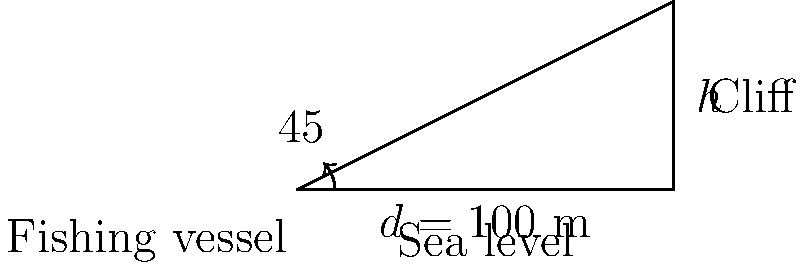A fishing vessel is positioned 100 meters from the base of a coastal cliff. Using a theodolite, the fisherman measures the angle of elevation to the top of the cliff to be 45°. What is the height of the cliff? To solve this problem, we can use trigonometry. Let's break it down step-by-step:

1) We have a right-angled triangle where:
   - The base (adjacent side) is the distance from the fishing vessel to the cliff: 100 meters
   - The angle of elevation is 45°
   - We need to find the height of the cliff (opposite side)

2) In a right-angled triangle, tan(angle) = opposite / adjacent

3) In this case:
   $\tan(45°) = \frac{height}{100}$

4) We know that $\tan(45°) = 1$, so our equation becomes:
   $1 = \frac{height}{100}$

5) Solving for height:
   $height = 1 * 100 = 100$ meters

Therefore, the height of the cliff is 100 meters.
Answer: 100 meters 